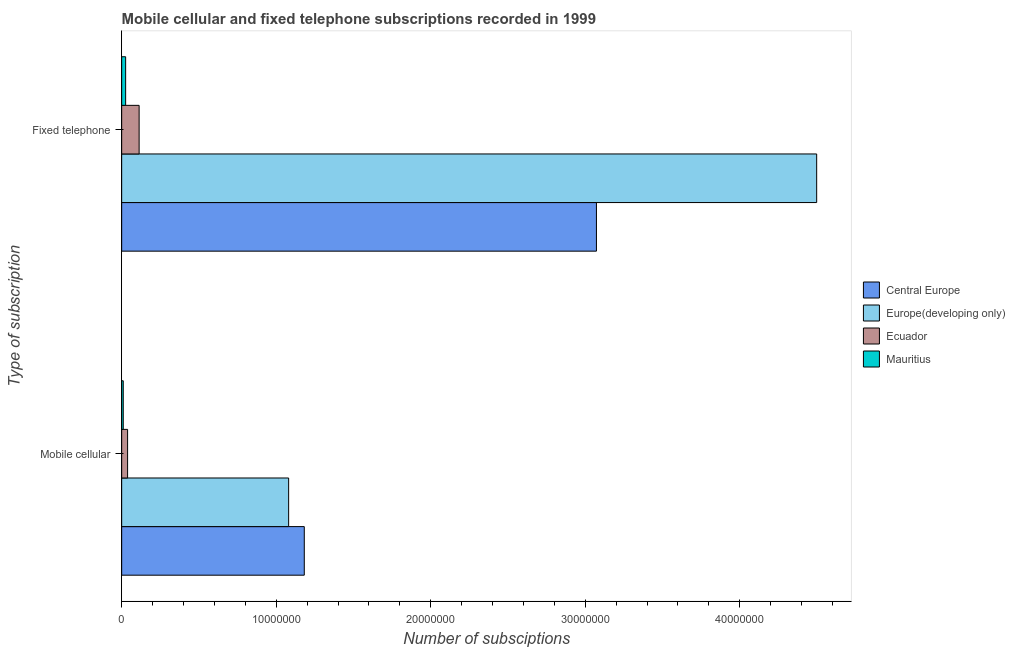How many groups of bars are there?
Your answer should be compact. 2. What is the label of the 2nd group of bars from the top?
Ensure brevity in your answer.  Mobile cellular. What is the number of mobile cellular subscriptions in Europe(developing only)?
Your answer should be compact. 1.08e+07. Across all countries, what is the maximum number of fixed telephone subscriptions?
Provide a short and direct response. 4.50e+07. Across all countries, what is the minimum number of mobile cellular subscriptions?
Keep it short and to the point. 1.02e+05. In which country was the number of mobile cellular subscriptions maximum?
Offer a very short reply. Central Europe. In which country was the number of mobile cellular subscriptions minimum?
Your response must be concise. Mauritius. What is the total number of mobile cellular subscriptions in the graph?
Your response must be concise. 2.31e+07. What is the difference between the number of mobile cellular subscriptions in Mauritius and that in Ecuador?
Offer a very short reply. -2.81e+05. What is the difference between the number of mobile cellular subscriptions in Mauritius and the number of fixed telephone subscriptions in Central Europe?
Keep it short and to the point. -3.06e+07. What is the average number of mobile cellular subscriptions per country?
Make the answer very short. 5.78e+06. What is the difference between the number of fixed telephone subscriptions and number of mobile cellular subscriptions in Mauritius?
Give a very brief answer. 1.55e+05. In how many countries, is the number of fixed telephone subscriptions greater than 18000000 ?
Offer a very short reply. 2. What is the ratio of the number of mobile cellular subscriptions in Mauritius to that in Europe(developing only)?
Your answer should be very brief. 0.01. Is the number of mobile cellular subscriptions in Mauritius less than that in Europe(developing only)?
Provide a succinct answer. Yes. In how many countries, is the number of mobile cellular subscriptions greater than the average number of mobile cellular subscriptions taken over all countries?
Your answer should be very brief. 2. What does the 2nd bar from the top in Mobile cellular represents?
Provide a short and direct response. Ecuador. What does the 2nd bar from the bottom in Mobile cellular represents?
Keep it short and to the point. Europe(developing only). How many bars are there?
Give a very brief answer. 8. Are all the bars in the graph horizontal?
Provide a succinct answer. Yes. What is the difference between two consecutive major ticks on the X-axis?
Give a very brief answer. 1.00e+07. Where does the legend appear in the graph?
Ensure brevity in your answer.  Center right. How many legend labels are there?
Give a very brief answer. 4. What is the title of the graph?
Offer a terse response. Mobile cellular and fixed telephone subscriptions recorded in 1999. Does "Burundi" appear as one of the legend labels in the graph?
Ensure brevity in your answer.  No. What is the label or title of the X-axis?
Your answer should be very brief. Number of subsciptions. What is the label or title of the Y-axis?
Your response must be concise. Type of subscription. What is the Number of subsciptions in Central Europe in Mobile cellular?
Your response must be concise. 1.18e+07. What is the Number of subsciptions of Europe(developing only) in Mobile cellular?
Your answer should be very brief. 1.08e+07. What is the Number of subsciptions of Ecuador in Mobile cellular?
Give a very brief answer. 3.83e+05. What is the Number of subsciptions of Mauritius in Mobile cellular?
Ensure brevity in your answer.  1.02e+05. What is the Number of subsciptions in Central Europe in Fixed telephone?
Your answer should be compact. 3.07e+07. What is the Number of subsciptions in Europe(developing only) in Fixed telephone?
Give a very brief answer. 4.50e+07. What is the Number of subsciptions of Ecuador in Fixed telephone?
Ensure brevity in your answer.  1.13e+06. What is the Number of subsciptions in Mauritius in Fixed telephone?
Your answer should be very brief. 2.57e+05. Across all Type of subscription, what is the maximum Number of subsciptions in Central Europe?
Keep it short and to the point. 3.07e+07. Across all Type of subscription, what is the maximum Number of subsciptions in Europe(developing only)?
Keep it short and to the point. 4.50e+07. Across all Type of subscription, what is the maximum Number of subsciptions of Ecuador?
Offer a very short reply. 1.13e+06. Across all Type of subscription, what is the maximum Number of subsciptions in Mauritius?
Provide a succinct answer. 2.57e+05. Across all Type of subscription, what is the minimum Number of subsciptions in Central Europe?
Offer a terse response. 1.18e+07. Across all Type of subscription, what is the minimum Number of subsciptions of Europe(developing only)?
Your answer should be very brief. 1.08e+07. Across all Type of subscription, what is the minimum Number of subsciptions in Ecuador?
Your response must be concise. 3.83e+05. Across all Type of subscription, what is the minimum Number of subsciptions in Mauritius?
Your response must be concise. 1.02e+05. What is the total Number of subsciptions in Central Europe in the graph?
Your response must be concise. 4.25e+07. What is the total Number of subsciptions in Europe(developing only) in the graph?
Make the answer very short. 5.58e+07. What is the total Number of subsciptions of Ecuador in the graph?
Keep it short and to the point. 1.51e+06. What is the total Number of subsciptions of Mauritius in the graph?
Give a very brief answer. 3.59e+05. What is the difference between the Number of subsciptions of Central Europe in Mobile cellular and that in Fixed telephone?
Provide a succinct answer. -1.89e+07. What is the difference between the Number of subsciptions of Europe(developing only) in Mobile cellular and that in Fixed telephone?
Keep it short and to the point. -3.42e+07. What is the difference between the Number of subsciptions in Ecuador in Mobile cellular and that in Fixed telephone?
Give a very brief answer. -7.46e+05. What is the difference between the Number of subsciptions in Mauritius in Mobile cellular and that in Fixed telephone?
Give a very brief answer. -1.55e+05. What is the difference between the Number of subsciptions in Central Europe in Mobile cellular and the Number of subsciptions in Europe(developing only) in Fixed telephone?
Your answer should be compact. -3.32e+07. What is the difference between the Number of subsciptions of Central Europe in Mobile cellular and the Number of subsciptions of Ecuador in Fixed telephone?
Make the answer very short. 1.07e+07. What is the difference between the Number of subsciptions of Central Europe in Mobile cellular and the Number of subsciptions of Mauritius in Fixed telephone?
Keep it short and to the point. 1.16e+07. What is the difference between the Number of subsciptions of Europe(developing only) in Mobile cellular and the Number of subsciptions of Ecuador in Fixed telephone?
Your answer should be very brief. 9.68e+06. What is the difference between the Number of subsciptions of Europe(developing only) in Mobile cellular and the Number of subsciptions of Mauritius in Fixed telephone?
Keep it short and to the point. 1.05e+07. What is the difference between the Number of subsciptions of Ecuador in Mobile cellular and the Number of subsciptions of Mauritius in Fixed telephone?
Give a very brief answer. 1.26e+05. What is the average Number of subsciptions in Central Europe per Type of subscription?
Provide a succinct answer. 2.13e+07. What is the average Number of subsciptions in Europe(developing only) per Type of subscription?
Provide a succinct answer. 2.79e+07. What is the average Number of subsciptions of Ecuador per Type of subscription?
Ensure brevity in your answer.  7.56e+05. What is the average Number of subsciptions in Mauritius per Type of subscription?
Ensure brevity in your answer.  1.80e+05. What is the difference between the Number of subsciptions of Central Europe and Number of subsciptions of Europe(developing only) in Mobile cellular?
Make the answer very short. 1.01e+06. What is the difference between the Number of subsciptions in Central Europe and Number of subsciptions in Ecuador in Mobile cellular?
Give a very brief answer. 1.14e+07. What is the difference between the Number of subsciptions in Central Europe and Number of subsciptions in Mauritius in Mobile cellular?
Make the answer very short. 1.17e+07. What is the difference between the Number of subsciptions in Europe(developing only) and Number of subsciptions in Ecuador in Mobile cellular?
Keep it short and to the point. 1.04e+07. What is the difference between the Number of subsciptions in Europe(developing only) and Number of subsciptions in Mauritius in Mobile cellular?
Provide a succinct answer. 1.07e+07. What is the difference between the Number of subsciptions of Ecuador and Number of subsciptions of Mauritius in Mobile cellular?
Offer a very short reply. 2.81e+05. What is the difference between the Number of subsciptions of Central Europe and Number of subsciptions of Europe(developing only) in Fixed telephone?
Give a very brief answer. -1.43e+07. What is the difference between the Number of subsciptions in Central Europe and Number of subsciptions in Ecuador in Fixed telephone?
Offer a terse response. 2.96e+07. What is the difference between the Number of subsciptions of Central Europe and Number of subsciptions of Mauritius in Fixed telephone?
Provide a short and direct response. 3.05e+07. What is the difference between the Number of subsciptions of Europe(developing only) and Number of subsciptions of Ecuador in Fixed telephone?
Provide a short and direct response. 4.38e+07. What is the difference between the Number of subsciptions in Europe(developing only) and Number of subsciptions in Mauritius in Fixed telephone?
Give a very brief answer. 4.47e+07. What is the difference between the Number of subsciptions in Ecuador and Number of subsciptions in Mauritius in Fixed telephone?
Ensure brevity in your answer.  8.72e+05. What is the ratio of the Number of subsciptions in Central Europe in Mobile cellular to that in Fixed telephone?
Offer a terse response. 0.38. What is the ratio of the Number of subsciptions in Europe(developing only) in Mobile cellular to that in Fixed telephone?
Your response must be concise. 0.24. What is the ratio of the Number of subsciptions in Ecuador in Mobile cellular to that in Fixed telephone?
Provide a succinct answer. 0.34. What is the ratio of the Number of subsciptions of Mauritius in Mobile cellular to that in Fixed telephone?
Make the answer very short. 0.4. What is the difference between the highest and the second highest Number of subsciptions in Central Europe?
Provide a short and direct response. 1.89e+07. What is the difference between the highest and the second highest Number of subsciptions of Europe(developing only)?
Your answer should be compact. 3.42e+07. What is the difference between the highest and the second highest Number of subsciptions of Ecuador?
Your response must be concise. 7.46e+05. What is the difference between the highest and the second highest Number of subsciptions of Mauritius?
Provide a succinct answer. 1.55e+05. What is the difference between the highest and the lowest Number of subsciptions in Central Europe?
Your answer should be very brief. 1.89e+07. What is the difference between the highest and the lowest Number of subsciptions of Europe(developing only)?
Your response must be concise. 3.42e+07. What is the difference between the highest and the lowest Number of subsciptions of Ecuador?
Keep it short and to the point. 7.46e+05. What is the difference between the highest and the lowest Number of subsciptions in Mauritius?
Your answer should be very brief. 1.55e+05. 